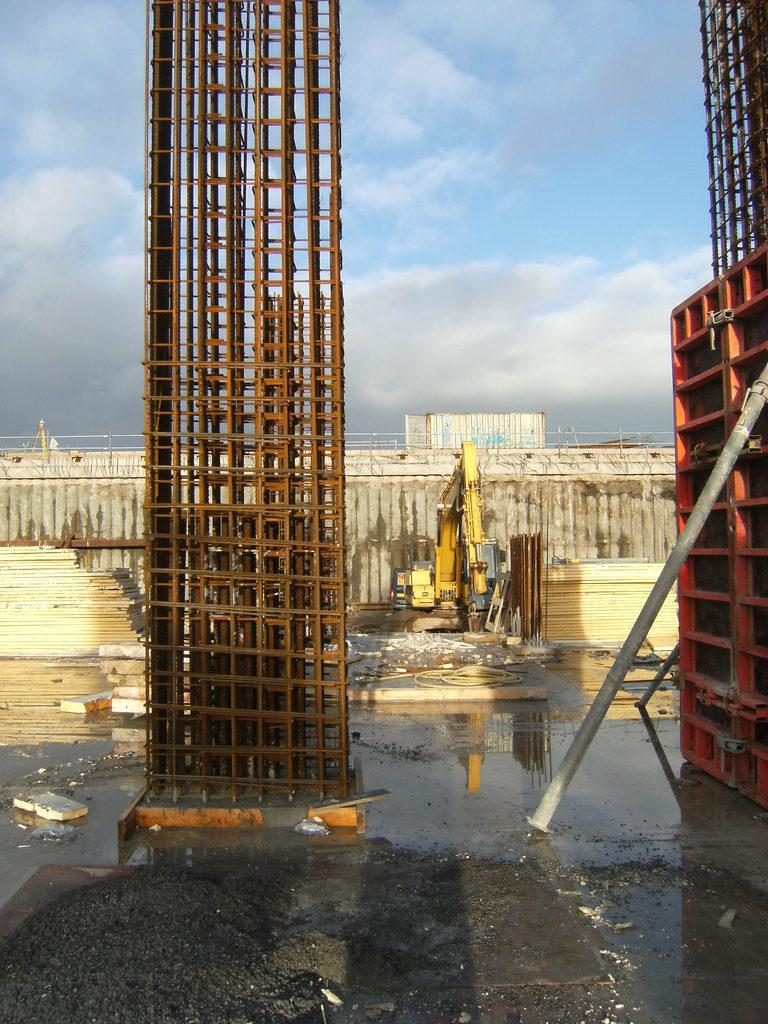What is the main subject in the image? There is an iron pillar in the image. What else can be seen in the image besides the iron pillar? There is water, a yellow vehicle, a fence, and the sky visible in the image. Can you describe the location of the yellow vehicle in the image? The yellow vehicle is in the background of the image. What is the color of the fence in the image? The color of the fence is not mentioned in the facts, so we cannot determine its color. How many fingers does the iron pillar have in the image? The iron pillar is an inanimate object and does not have fingers. 